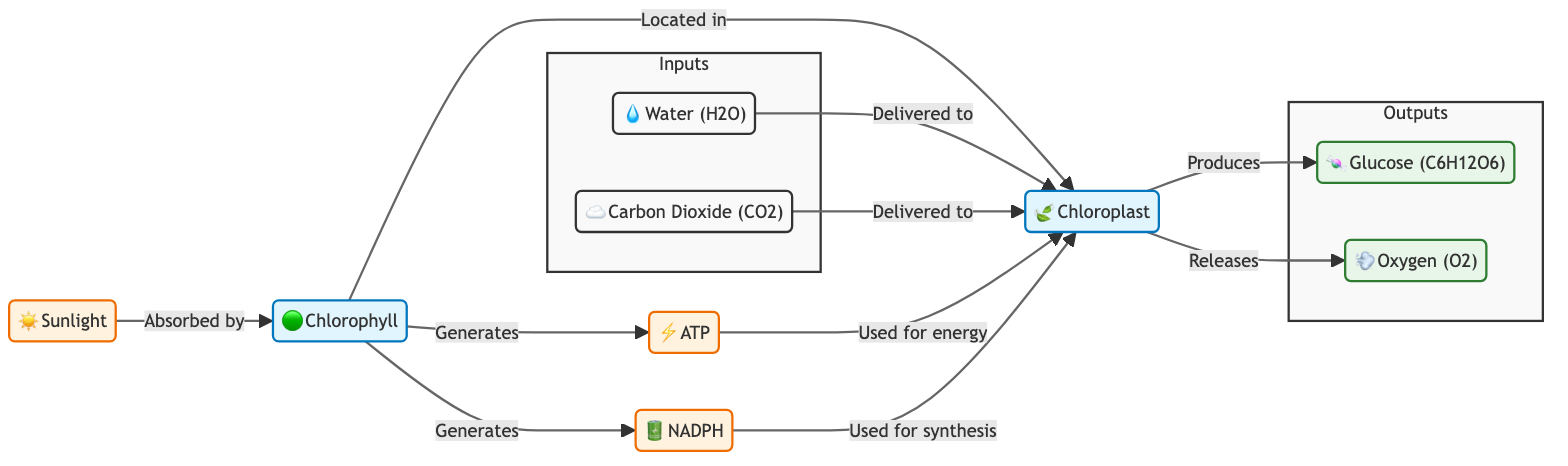What is the source of energy in the photosynthesis process? The diagram indicates that the source of energy is "☀️ Sunlight." This is the first node that provides energy, which is absorbed by chlorophyll to facilitate the process.
Answer: Sunlight How many products are generated in the photosynthesis process? From the diagram, we see that there are two outputs listed under the "Outputs" subgraph: "🍬 Glucose" and "💨 Oxygen." Therefore, the number of products generated is two.
Answer: 2 Which process generates ATP? The diagram shows that "Chlorophyll" is responsible for generating ATP. It is connected to the process node and has an arrow pointing to ATP, indicating its role in the photosynthesis process.
Answer: Chlorophyll What compounds are delivered to the chloroplast during photosynthesis? The diagram specifies that "💧 Water (H2O)" and "☁️ Carbon Dioxide (CO2)" are delivered to the chloroplast, as shown by the arrows leading into the chloroplast node from these inputs.
Answer: Water, Carbon Dioxide What is the primary product of the chloroplast? The diagram illustrates that the primary product generated by the chloroplast is "🍬 Glucose (C6H12O6)." This node is prominently shown in the outputs section.
Answer: Glucose How does chlorophyll contribute to the photosynthesis process? The diagram outlines that chlorophyll generates both ATP and NADPH, showcasing its dual role in providing energy and reducing power to the chloroplast for synthesis.
Answer: Generates ATP and NADPH What do chloroplasts release as part of the photosynthesis process? According to the diagram, the chloroplast releases "💨 Oxygen (O2)" as one of the outputs, clearly indicated by the arrow pointing from the chloroplast to the oxygen node.
Answer: Oxygen Which energy carrier is produced alongside ATP in the chlorophyll process? The diagram specifies that "🔋 NADPH" is also produced in conjunction with ATP by the chlorophyll. The arrows from chlorophyll lead to both ATP and NADPH, indicating their simultaneous production.
Answer: NADPH What are the inputs required for the process of photosynthesis? The diagram has a subgraph labeled "Inputs," clearly showing that "💧 Water" and "☁️ Carbon Dioxide" are required for photosynthesis as indicated by their presence in this section.
Answer: Water, Carbon Dioxide 